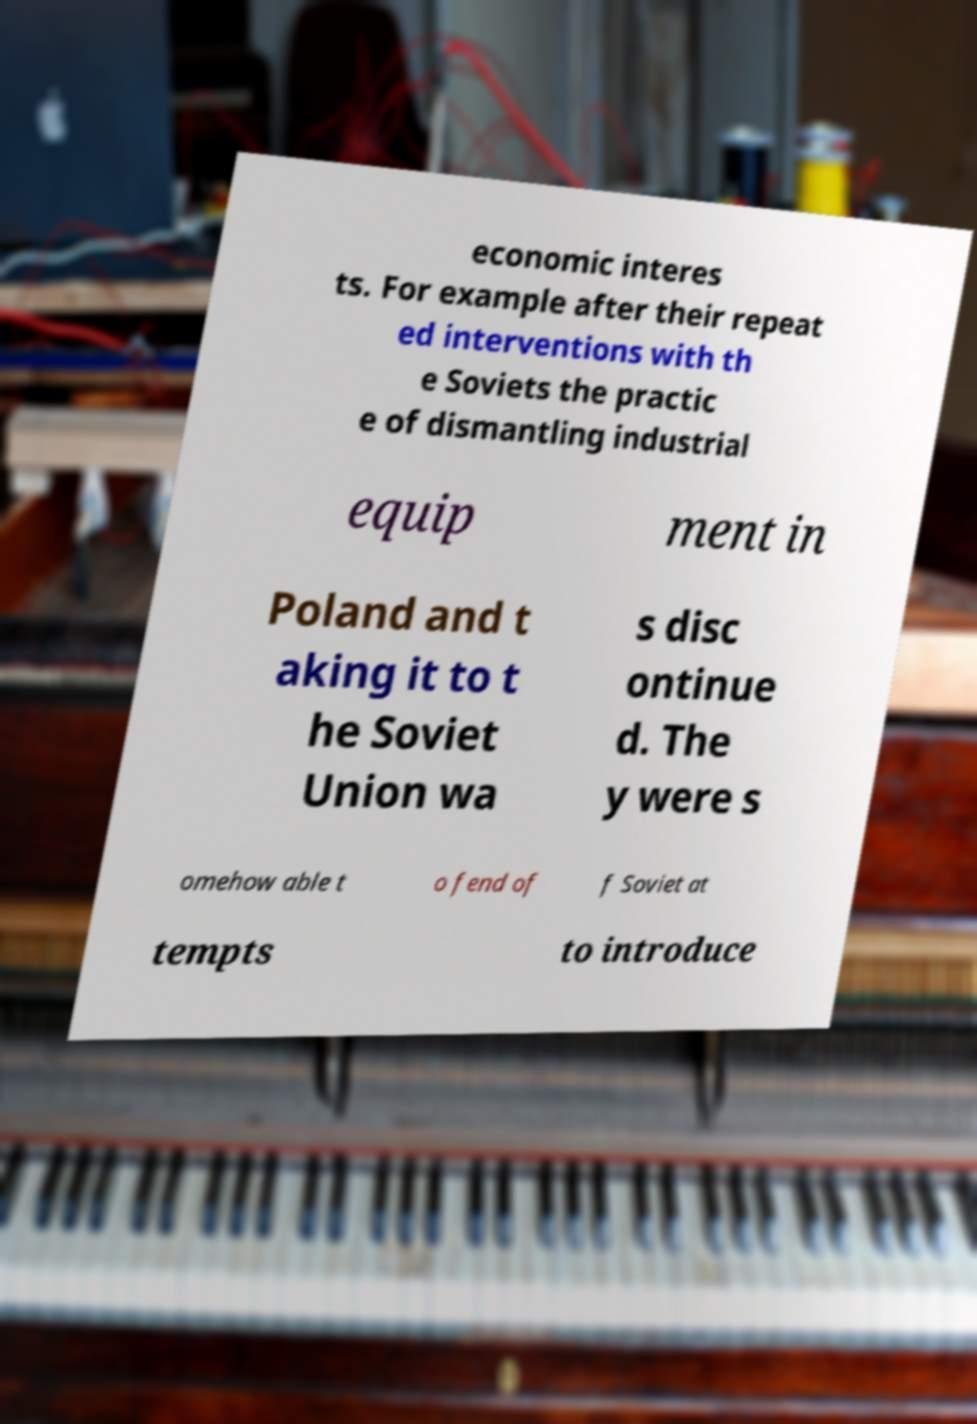Can you accurately transcribe the text from the provided image for me? economic interes ts. For example after their repeat ed interventions with th e Soviets the practic e of dismantling industrial equip ment in Poland and t aking it to t he Soviet Union wa s disc ontinue d. The y were s omehow able t o fend of f Soviet at tempts to introduce 